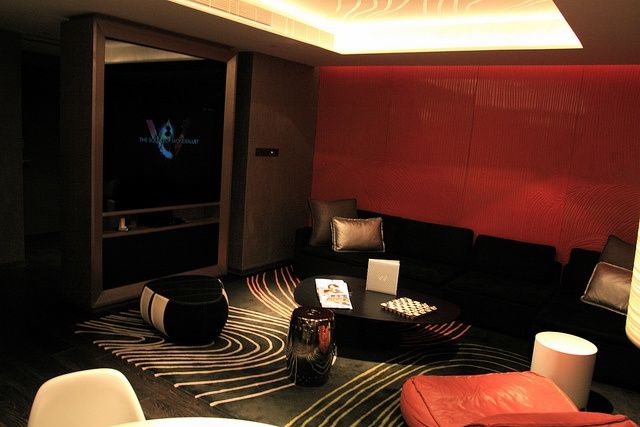Describe the objects in this image and their specific colors. I can see tv in black, gray, and maroon tones, couch in black, maroon, and gray tones, chair in black, red, salmon, and brown tones, chair in black, tan, and lightyellow tones, and laptop in black and tan tones in this image. 